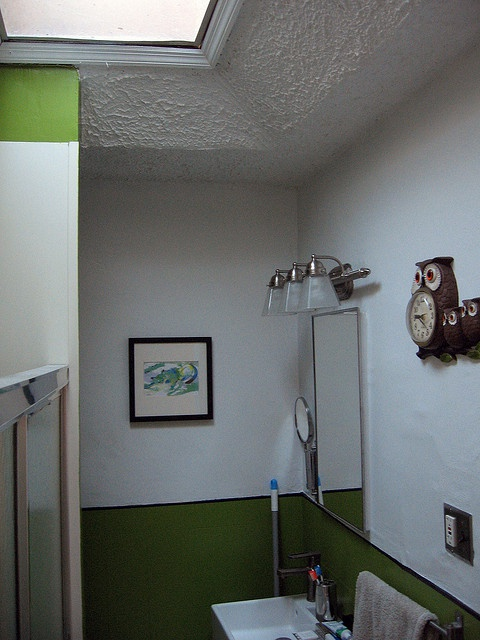Describe the objects in this image and their specific colors. I can see sink in darkgray, gray, and black tones, clock in darkgray, gray, and black tones, tennis racket in darkgray, gray, and black tones, toothbrush in darkgray, brown, black, and gray tones, and toothbrush in darkgray, navy, black, darkblue, and gray tones in this image. 